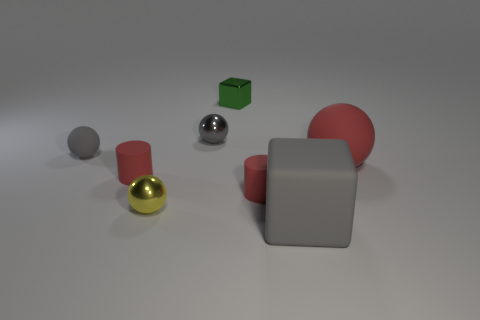What color is the shiny ball that is in front of the rubber sphere on the right side of the gray object that is to the right of the tiny green object?
Your answer should be very brief. Yellow. Does the small yellow thing have the same material as the red ball?
Make the answer very short. No. How many red things are either large matte objects or rubber cylinders?
Keep it short and to the point. 3. There is a big red rubber thing; what number of gray matte things are in front of it?
Provide a short and direct response. 1. Is the number of gray metallic spheres greater than the number of gray things?
Make the answer very short. No. The tiny red matte thing that is to the right of the cube behind the big rubber sphere is what shape?
Your response must be concise. Cylinder. Is the matte cube the same color as the tiny matte sphere?
Ensure brevity in your answer.  Yes. Is the number of small matte things that are on the right side of the small green thing greater than the number of tiny blue cylinders?
Offer a terse response. Yes. There is a tiny metallic ball that is behind the large rubber sphere; what number of metal things are to the left of it?
Your answer should be compact. 1. Does the large red ball on the right side of the metallic block have the same material as the tiny yellow thing on the left side of the gray rubber block?
Provide a short and direct response. No. 